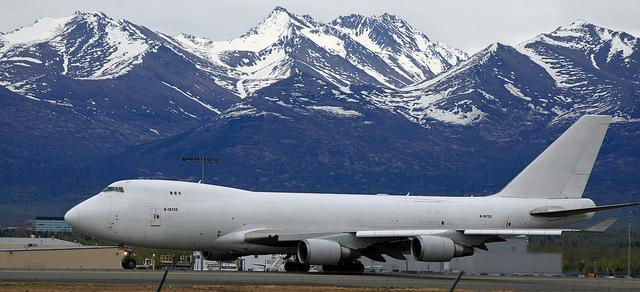How many airplanes are in the photo?
Give a very brief answer. 1. How many blue ties are there?
Give a very brief answer. 0. 